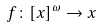Convert formula to latex. <formula><loc_0><loc_0><loc_500><loc_500>f \colon [ x ] ^ { \omega } \to x</formula> 